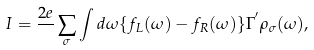<formula> <loc_0><loc_0><loc_500><loc_500>I = \frac { 2 e } { } \sum _ { \sigma } \int d \omega \{ f _ { L } ( \omega ) - f _ { R } ( \omega ) \} \Gamma ^ { ^ { \prime } } \rho _ { \sigma } ( \omega ) ,</formula> 